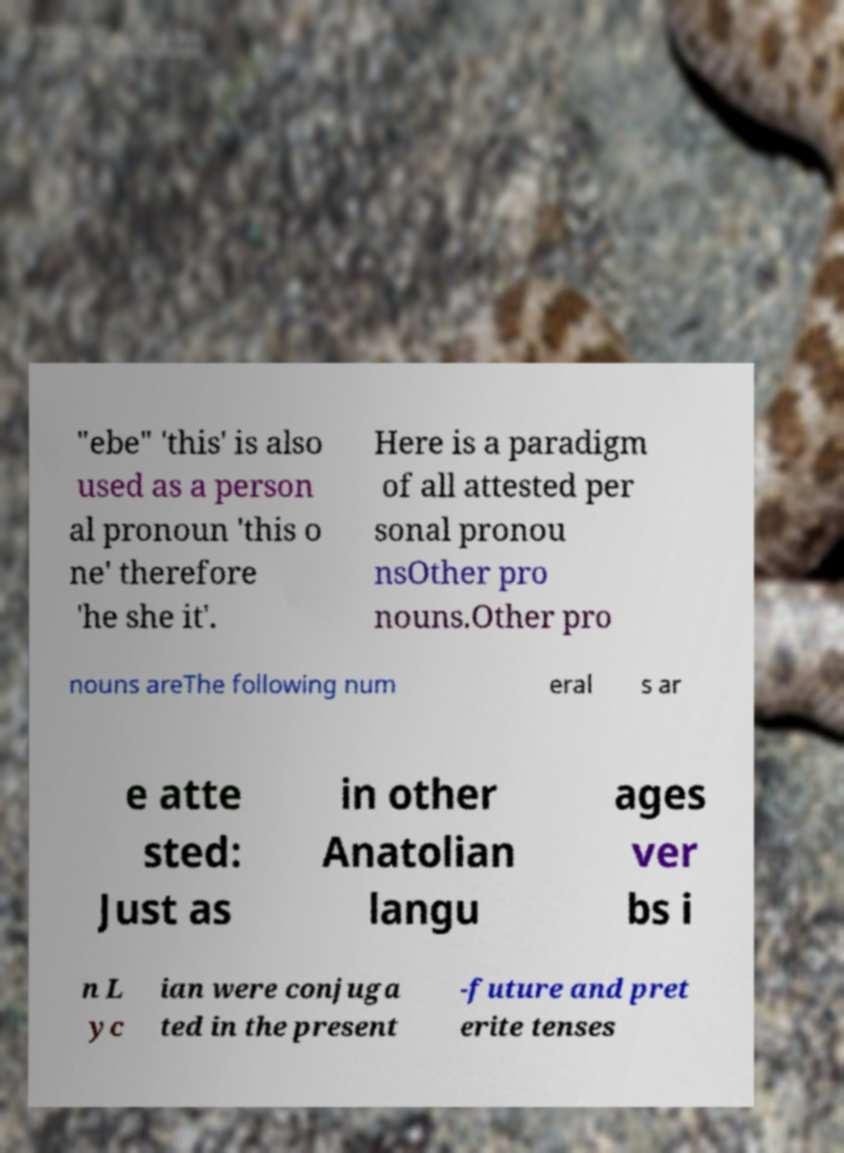I need the written content from this picture converted into text. Can you do that? "ebe" 'this' is also used as a person al pronoun 'this o ne' therefore 'he she it'. Here is a paradigm of all attested per sonal pronou nsOther pro nouns.Other pro nouns areThe following num eral s ar e atte sted: Just as in other Anatolian langu ages ver bs i n L yc ian were conjuga ted in the present -future and pret erite tenses 